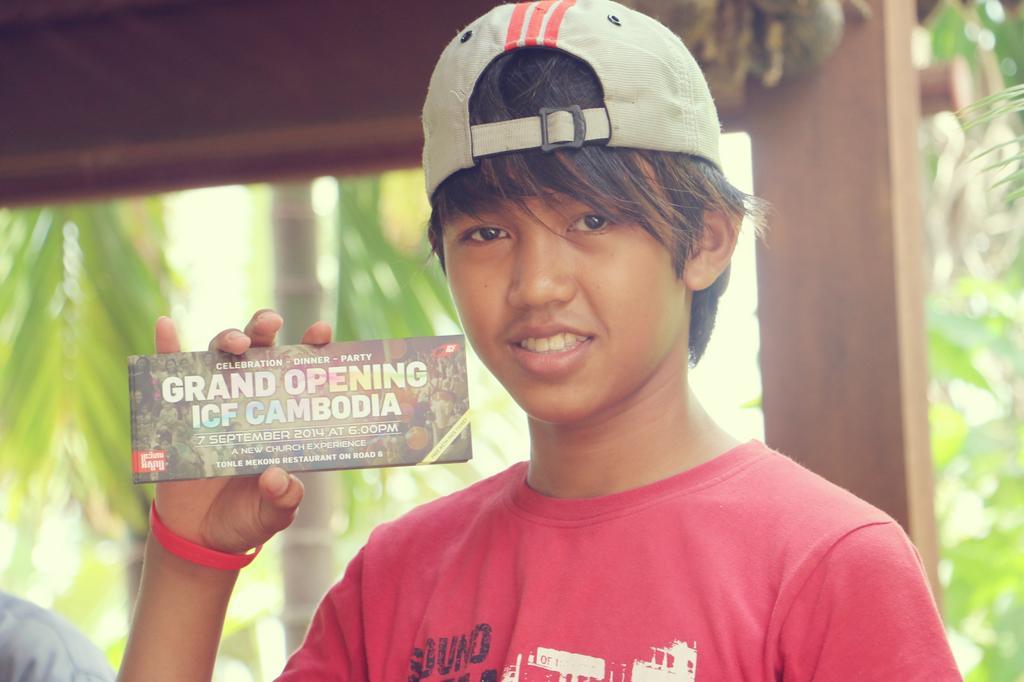Please provide a concise description of this image. In this image I can see a person wearing red colored t shirt and cream colored cap is holding an object in his hand. I can see the blurry background in which I can see few trees and few other objects. 